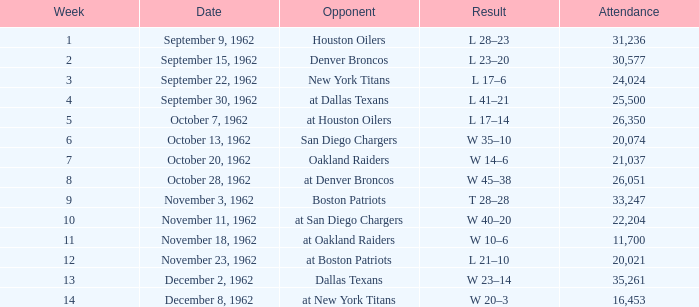In which week on december 8, 1962, was there a lower attendance than 22,204? 14.0. 